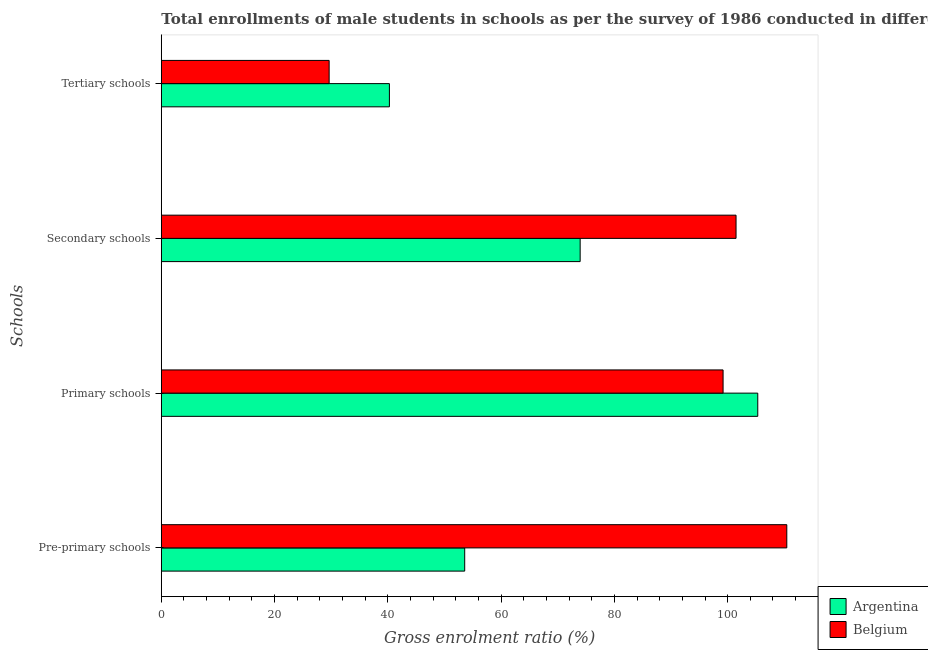How many different coloured bars are there?
Your answer should be very brief. 2. How many groups of bars are there?
Provide a succinct answer. 4. Are the number of bars on each tick of the Y-axis equal?
Offer a terse response. Yes. What is the label of the 4th group of bars from the top?
Ensure brevity in your answer.  Pre-primary schools. What is the gross enrolment ratio(male) in primary schools in Argentina?
Your answer should be very brief. 105.32. Across all countries, what is the maximum gross enrolment ratio(male) in tertiary schools?
Your answer should be very brief. 40.27. Across all countries, what is the minimum gross enrolment ratio(male) in secondary schools?
Provide a succinct answer. 73.96. In which country was the gross enrolment ratio(male) in secondary schools maximum?
Offer a very short reply. Belgium. What is the total gross enrolment ratio(male) in secondary schools in the graph?
Offer a terse response. 175.44. What is the difference between the gross enrolment ratio(male) in primary schools in Belgium and that in Argentina?
Keep it short and to the point. -6.12. What is the difference between the gross enrolment ratio(male) in primary schools in Argentina and the gross enrolment ratio(male) in pre-primary schools in Belgium?
Your answer should be very brief. -5.13. What is the average gross enrolment ratio(male) in pre-primary schools per country?
Your answer should be compact. 82.01. What is the difference between the gross enrolment ratio(male) in pre-primary schools and gross enrolment ratio(male) in primary schools in Argentina?
Provide a succinct answer. -51.75. What is the ratio of the gross enrolment ratio(male) in tertiary schools in Argentina to that in Belgium?
Give a very brief answer. 1.36. Is the difference between the gross enrolment ratio(male) in secondary schools in Belgium and Argentina greater than the difference between the gross enrolment ratio(male) in primary schools in Belgium and Argentina?
Ensure brevity in your answer.  Yes. What is the difference between the highest and the second highest gross enrolment ratio(male) in tertiary schools?
Offer a very short reply. 10.64. What is the difference between the highest and the lowest gross enrolment ratio(male) in tertiary schools?
Provide a short and direct response. 10.64. In how many countries, is the gross enrolment ratio(male) in tertiary schools greater than the average gross enrolment ratio(male) in tertiary schools taken over all countries?
Your answer should be very brief. 1. Is the sum of the gross enrolment ratio(male) in tertiary schools in Argentina and Belgium greater than the maximum gross enrolment ratio(male) in primary schools across all countries?
Offer a very short reply. No. Is it the case that in every country, the sum of the gross enrolment ratio(male) in primary schools and gross enrolment ratio(male) in pre-primary schools is greater than the sum of gross enrolment ratio(male) in tertiary schools and gross enrolment ratio(male) in secondary schools?
Keep it short and to the point. No. What does the 2nd bar from the top in Tertiary schools represents?
Offer a very short reply. Argentina. What does the 1st bar from the bottom in Tertiary schools represents?
Give a very brief answer. Argentina. Is it the case that in every country, the sum of the gross enrolment ratio(male) in pre-primary schools and gross enrolment ratio(male) in primary schools is greater than the gross enrolment ratio(male) in secondary schools?
Your answer should be compact. Yes. How many bars are there?
Provide a succinct answer. 8. How many countries are there in the graph?
Offer a terse response. 2. Are the values on the major ticks of X-axis written in scientific E-notation?
Give a very brief answer. No. Does the graph contain grids?
Offer a terse response. No. How many legend labels are there?
Provide a short and direct response. 2. How are the legend labels stacked?
Your response must be concise. Vertical. What is the title of the graph?
Your answer should be very brief. Total enrollments of male students in schools as per the survey of 1986 conducted in different countries. Does "Oman" appear as one of the legend labels in the graph?
Keep it short and to the point. No. What is the label or title of the Y-axis?
Keep it short and to the point. Schools. What is the Gross enrolment ratio (%) of Argentina in Pre-primary schools?
Your answer should be very brief. 53.57. What is the Gross enrolment ratio (%) in Belgium in Pre-primary schools?
Keep it short and to the point. 110.44. What is the Gross enrolment ratio (%) in Argentina in Primary schools?
Provide a succinct answer. 105.32. What is the Gross enrolment ratio (%) of Belgium in Primary schools?
Offer a very short reply. 99.19. What is the Gross enrolment ratio (%) of Argentina in Secondary schools?
Give a very brief answer. 73.96. What is the Gross enrolment ratio (%) of Belgium in Secondary schools?
Your answer should be very brief. 101.48. What is the Gross enrolment ratio (%) in Argentina in Tertiary schools?
Provide a short and direct response. 40.27. What is the Gross enrolment ratio (%) of Belgium in Tertiary schools?
Keep it short and to the point. 29.63. Across all Schools, what is the maximum Gross enrolment ratio (%) of Argentina?
Provide a short and direct response. 105.32. Across all Schools, what is the maximum Gross enrolment ratio (%) of Belgium?
Give a very brief answer. 110.44. Across all Schools, what is the minimum Gross enrolment ratio (%) in Argentina?
Make the answer very short. 40.27. Across all Schools, what is the minimum Gross enrolment ratio (%) of Belgium?
Give a very brief answer. 29.63. What is the total Gross enrolment ratio (%) of Argentina in the graph?
Provide a succinct answer. 273.12. What is the total Gross enrolment ratio (%) of Belgium in the graph?
Your answer should be compact. 340.75. What is the difference between the Gross enrolment ratio (%) of Argentina in Pre-primary schools and that in Primary schools?
Provide a short and direct response. -51.75. What is the difference between the Gross enrolment ratio (%) of Belgium in Pre-primary schools and that in Primary schools?
Make the answer very short. 11.25. What is the difference between the Gross enrolment ratio (%) in Argentina in Pre-primary schools and that in Secondary schools?
Provide a succinct answer. -20.39. What is the difference between the Gross enrolment ratio (%) of Belgium in Pre-primary schools and that in Secondary schools?
Provide a succinct answer. 8.96. What is the difference between the Gross enrolment ratio (%) in Argentina in Pre-primary schools and that in Tertiary schools?
Offer a terse response. 13.3. What is the difference between the Gross enrolment ratio (%) in Belgium in Pre-primary schools and that in Tertiary schools?
Offer a very short reply. 80.81. What is the difference between the Gross enrolment ratio (%) of Argentina in Primary schools and that in Secondary schools?
Ensure brevity in your answer.  31.36. What is the difference between the Gross enrolment ratio (%) in Belgium in Primary schools and that in Secondary schools?
Make the answer very short. -2.29. What is the difference between the Gross enrolment ratio (%) in Argentina in Primary schools and that in Tertiary schools?
Offer a terse response. 65.04. What is the difference between the Gross enrolment ratio (%) in Belgium in Primary schools and that in Tertiary schools?
Make the answer very short. 69.56. What is the difference between the Gross enrolment ratio (%) in Argentina in Secondary schools and that in Tertiary schools?
Your response must be concise. 33.68. What is the difference between the Gross enrolment ratio (%) in Belgium in Secondary schools and that in Tertiary schools?
Your answer should be compact. 71.85. What is the difference between the Gross enrolment ratio (%) of Argentina in Pre-primary schools and the Gross enrolment ratio (%) of Belgium in Primary schools?
Your response must be concise. -45.62. What is the difference between the Gross enrolment ratio (%) in Argentina in Pre-primary schools and the Gross enrolment ratio (%) in Belgium in Secondary schools?
Ensure brevity in your answer.  -47.91. What is the difference between the Gross enrolment ratio (%) of Argentina in Pre-primary schools and the Gross enrolment ratio (%) of Belgium in Tertiary schools?
Provide a short and direct response. 23.94. What is the difference between the Gross enrolment ratio (%) of Argentina in Primary schools and the Gross enrolment ratio (%) of Belgium in Secondary schools?
Offer a terse response. 3.84. What is the difference between the Gross enrolment ratio (%) of Argentina in Primary schools and the Gross enrolment ratio (%) of Belgium in Tertiary schools?
Ensure brevity in your answer.  75.68. What is the difference between the Gross enrolment ratio (%) in Argentina in Secondary schools and the Gross enrolment ratio (%) in Belgium in Tertiary schools?
Keep it short and to the point. 44.32. What is the average Gross enrolment ratio (%) of Argentina per Schools?
Ensure brevity in your answer.  68.28. What is the average Gross enrolment ratio (%) in Belgium per Schools?
Ensure brevity in your answer.  85.19. What is the difference between the Gross enrolment ratio (%) of Argentina and Gross enrolment ratio (%) of Belgium in Pre-primary schools?
Your answer should be very brief. -56.87. What is the difference between the Gross enrolment ratio (%) in Argentina and Gross enrolment ratio (%) in Belgium in Primary schools?
Make the answer very short. 6.12. What is the difference between the Gross enrolment ratio (%) of Argentina and Gross enrolment ratio (%) of Belgium in Secondary schools?
Offer a terse response. -27.53. What is the difference between the Gross enrolment ratio (%) in Argentina and Gross enrolment ratio (%) in Belgium in Tertiary schools?
Your response must be concise. 10.64. What is the ratio of the Gross enrolment ratio (%) in Argentina in Pre-primary schools to that in Primary schools?
Give a very brief answer. 0.51. What is the ratio of the Gross enrolment ratio (%) in Belgium in Pre-primary schools to that in Primary schools?
Your answer should be compact. 1.11. What is the ratio of the Gross enrolment ratio (%) in Argentina in Pre-primary schools to that in Secondary schools?
Offer a terse response. 0.72. What is the ratio of the Gross enrolment ratio (%) in Belgium in Pre-primary schools to that in Secondary schools?
Provide a succinct answer. 1.09. What is the ratio of the Gross enrolment ratio (%) of Argentina in Pre-primary schools to that in Tertiary schools?
Your answer should be compact. 1.33. What is the ratio of the Gross enrolment ratio (%) of Belgium in Pre-primary schools to that in Tertiary schools?
Give a very brief answer. 3.73. What is the ratio of the Gross enrolment ratio (%) of Argentina in Primary schools to that in Secondary schools?
Ensure brevity in your answer.  1.42. What is the ratio of the Gross enrolment ratio (%) in Belgium in Primary schools to that in Secondary schools?
Provide a short and direct response. 0.98. What is the ratio of the Gross enrolment ratio (%) of Argentina in Primary schools to that in Tertiary schools?
Ensure brevity in your answer.  2.61. What is the ratio of the Gross enrolment ratio (%) of Belgium in Primary schools to that in Tertiary schools?
Give a very brief answer. 3.35. What is the ratio of the Gross enrolment ratio (%) of Argentina in Secondary schools to that in Tertiary schools?
Offer a very short reply. 1.84. What is the ratio of the Gross enrolment ratio (%) of Belgium in Secondary schools to that in Tertiary schools?
Offer a terse response. 3.42. What is the difference between the highest and the second highest Gross enrolment ratio (%) in Argentina?
Provide a succinct answer. 31.36. What is the difference between the highest and the second highest Gross enrolment ratio (%) of Belgium?
Your answer should be very brief. 8.96. What is the difference between the highest and the lowest Gross enrolment ratio (%) in Argentina?
Make the answer very short. 65.04. What is the difference between the highest and the lowest Gross enrolment ratio (%) of Belgium?
Ensure brevity in your answer.  80.81. 